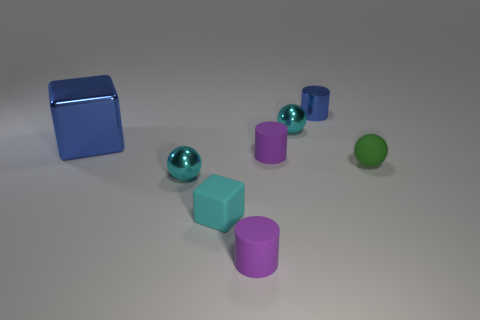Add 1 purple objects. How many objects exist? 9 Subtract all cylinders. How many objects are left? 5 Subtract all tiny green things. Subtract all large blue rubber balls. How many objects are left? 7 Add 4 small purple rubber objects. How many small purple rubber objects are left? 6 Add 4 small purple things. How many small purple things exist? 6 Subtract 1 cyan blocks. How many objects are left? 7 